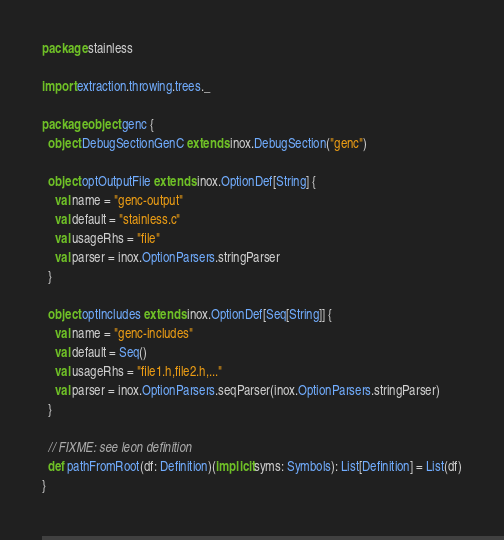Convert code to text. <code><loc_0><loc_0><loc_500><loc_500><_Scala_>package stainless

import extraction.throwing.trees._

package object genc {
  object DebugSectionGenC extends inox.DebugSection("genc")

  object optOutputFile extends inox.OptionDef[String] {
    val name = "genc-output"
    val default = "stainless.c"
    val usageRhs = "file"
    val parser = inox.OptionParsers.stringParser
  }

  object optIncludes extends inox.OptionDef[Seq[String]] {
    val name = "genc-includes"
    val default = Seq()
    val usageRhs = "file1.h,file2.h,..."
    val parser = inox.OptionParsers.seqParser(inox.OptionParsers.stringParser)
  }

  // FIXME: see leon definition
  def pathFromRoot(df: Definition)(implicit syms: Symbols): List[Definition] = List(df)
}
</code> 